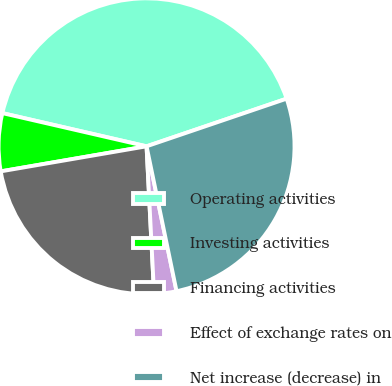Convert chart to OTSL. <chart><loc_0><loc_0><loc_500><loc_500><pie_chart><fcel>Operating activities<fcel>Investing activities<fcel>Financing activities<fcel>Effect of exchange rates on<fcel>Net increase (decrease) in<nl><fcel>41.18%<fcel>6.31%<fcel>23.1%<fcel>2.44%<fcel>26.97%<nl></chart> 